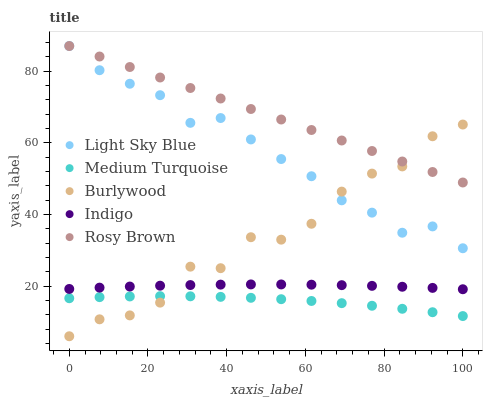Does Medium Turquoise have the minimum area under the curve?
Answer yes or no. Yes. Does Rosy Brown have the maximum area under the curve?
Answer yes or no. Yes. Does Light Sky Blue have the minimum area under the curve?
Answer yes or no. No. Does Light Sky Blue have the maximum area under the curve?
Answer yes or no. No. Is Rosy Brown the smoothest?
Answer yes or no. Yes. Is Burlywood the roughest?
Answer yes or no. Yes. Is Light Sky Blue the smoothest?
Answer yes or no. No. Is Light Sky Blue the roughest?
Answer yes or no. No. Does Burlywood have the lowest value?
Answer yes or no. Yes. Does Light Sky Blue have the lowest value?
Answer yes or no. No. Does Light Sky Blue have the highest value?
Answer yes or no. Yes. Does Indigo have the highest value?
Answer yes or no. No. Is Medium Turquoise less than Light Sky Blue?
Answer yes or no. Yes. Is Light Sky Blue greater than Indigo?
Answer yes or no. Yes. Does Burlywood intersect Rosy Brown?
Answer yes or no. Yes. Is Burlywood less than Rosy Brown?
Answer yes or no. No. Is Burlywood greater than Rosy Brown?
Answer yes or no. No. Does Medium Turquoise intersect Light Sky Blue?
Answer yes or no. No. 